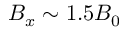Convert formula to latex. <formula><loc_0><loc_0><loc_500><loc_500>B _ { x } \sim 1 . 5 B _ { 0 }</formula> 